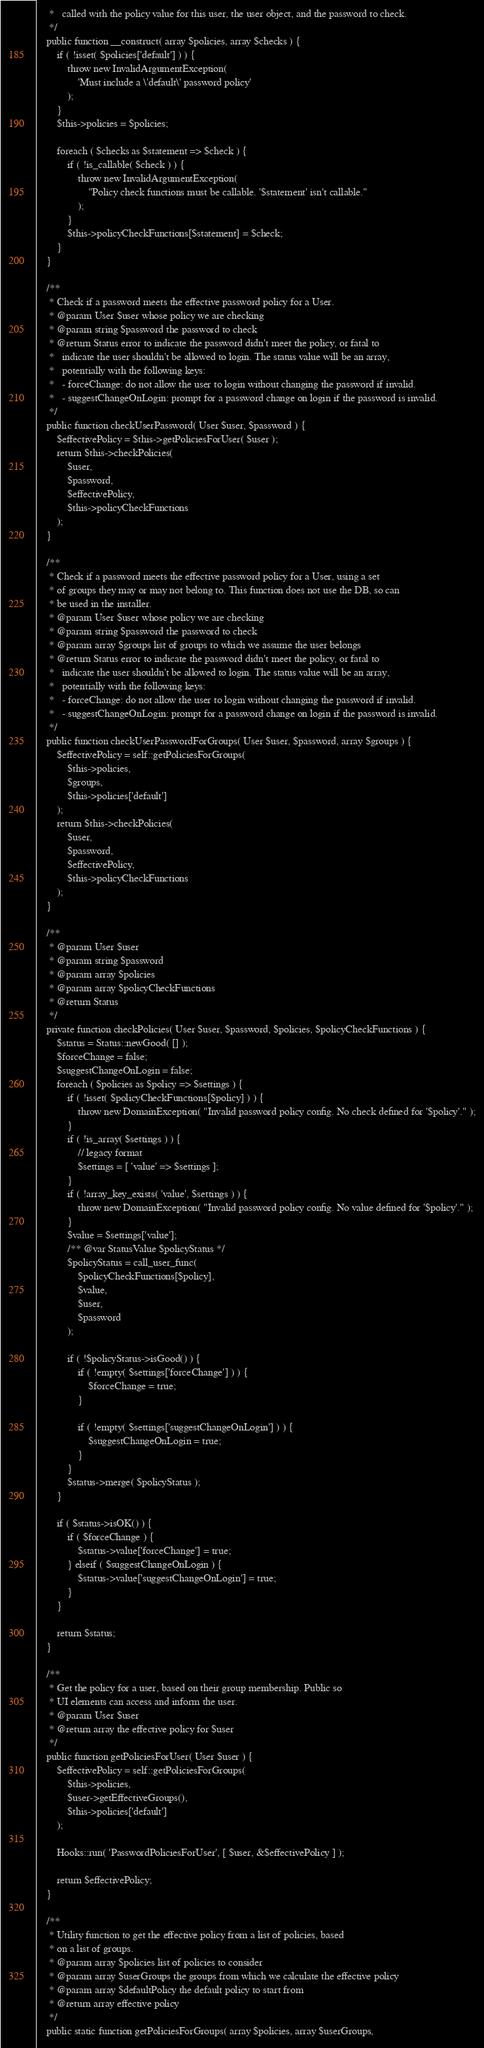Convert code to text. <code><loc_0><loc_0><loc_500><loc_500><_PHP_>	 *   called with the policy value for this user, the user object, and the password to check.
	 */
	public function __construct( array $policies, array $checks ) {
		if ( !isset( $policies['default'] ) ) {
			throw new InvalidArgumentException(
				'Must include a \'default\' password policy'
			);
		}
		$this->policies = $policies;

		foreach ( $checks as $statement => $check ) {
			if ( !is_callable( $check ) ) {
				throw new InvalidArgumentException(
					"Policy check functions must be callable. '$statement' isn't callable."
				);
			}
			$this->policyCheckFunctions[$statement] = $check;
		}
	}

	/**
	 * Check if a password meets the effective password policy for a User.
	 * @param User $user whose policy we are checking
	 * @param string $password the password to check
	 * @return Status error to indicate the password didn't meet the policy, or fatal to
	 *   indicate the user shouldn't be allowed to login. The status value will be an array,
	 *   potentially with the following keys:
	 *   - forceChange: do not allow the user to login without changing the password if invalid.
	 *   - suggestChangeOnLogin: prompt for a password change on login if the password is invalid.
	 */
	public function checkUserPassword( User $user, $password ) {
		$effectivePolicy = $this->getPoliciesForUser( $user );
		return $this->checkPolicies(
			$user,
			$password,
			$effectivePolicy,
			$this->policyCheckFunctions
		);
	}

	/**
	 * Check if a password meets the effective password policy for a User, using a set
	 * of groups they may or may not belong to. This function does not use the DB, so can
	 * be used in the installer.
	 * @param User $user whose policy we are checking
	 * @param string $password the password to check
	 * @param array $groups list of groups to which we assume the user belongs
	 * @return Status error to indicate the password didn't meet the policy, or fatal to
	 *   indicate the user shouldn't be allowed to login. The status value will be an array,
	 *   potentially with the following keys:
	 *   - forceChange: do not allow the user to login without changing the password if invalid.
	 *   - suggestChangeOnLogin: prompt for a password change on login if the password is invalid.
	 */
	public function checkUserPasswordForGroups( User $user, $password, array $groups ) {
		$effectivePolicy = self::getPoliciesForGroups(
			$this->policies,
			$groups,
			$this->policies['default']
		);
		return $this->checkPolicies(
			$user,
			$password,
			$effectivePolicy,
			$this->policyCheckFunctions
		);
	}

	/**
	 * @param User $user
	 * @param string $password
	 * @param array $policies
	 * @param array $policyCheckFunctions
	 * @return Status
	 */
	private function checkPolicies( User $user, $password, $policies, $policyCheckFunctions ) {
		$status = Status::newGood( [] );
		$forceChange = false;
		$suggestChangeOnLogin = false;
		foreach ( $policies as $policy => $settings ) {
			if ( !isset( $policyCheckFunctions[$policy] ) ) {
				throw new DomainException( "Invalid password policy config. No check defined for '$policy'." );
			}
			if ( !is_array( $settings ) ) {
				// legacy format
				$settings = [ 'value' => $settings ];
			}
			if ( !array_key_exists( 'value', $settings ) ) {
				throw new DomainException( "Invalid password policy config. No value defined for '$policy'." );
			}
			$value = $settings['value'];
			/** @var StatusValue $policyStatus */
			$policyStatus = call_user_func(
				$policyCheckFunctions[$policy],
				$value,
				$user,
				$password
			);

			if ( !$policyStatus->isGood() ) {
				if ( !empty( $settings['forceChange'] ) ) {
					$forceChange = true;
				}

				if ( !empty( $settings['suggestChangeOnLogin'] ) ) {
					$suggestChangeOnLogin = true;
				}
			}
			$status->merge( $policyStatus );
		}

		if ( $status->isOK() ) {
			if ( $forceChange ) {
				$status->value['forceChange'] = true;
			} elseif ( $suggestChangeOnLogin ) {
				$status->value['suggestChangeOnLogin'] = true;
			}
		}

		return $status;
	}

	/**
	 * Get the policy for a user, based on their group membership. Public so
	 * UI elements can access and inform the user.
	 * @param User $user
	 * @return array the effective policy for $user
	 */
	public function getPoliciesForUser( User $user ) {
		$effectivePolicy = self::getPoliciesForGroups(
			$this->policies,
			$user->getEffectiveGroups(),
			$this->policies['default']
		);

		Hooks::run( 'PasswordPoliciesForUser', [ $user, &$effectivePolicy ] );

		return $effectivePolicy;
	}

	/**
	 * Utility function to get the effective policy from a list of policies, based
	 * on a list of groups.
	 * @param array $policies list of policies to consider
	 * @param array $userGroups the groups from which we calculate the effective policy
	 * @param array $defaultPolicy the default policy to start from
	 * @return array effective policy
	 */
	public static function getPoliciesForGroups( array $policies, array $userGroups,</code> 